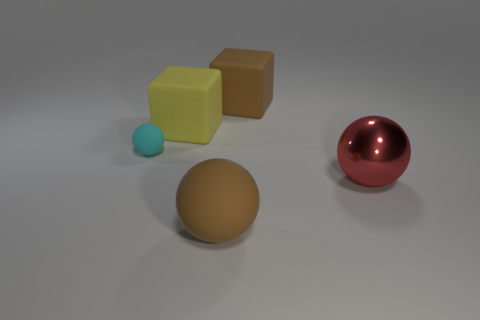Are there any tiny yellow balls made of the same material as the large yellow block?
Your answer should be very brief. No. There is a yellow thing; what shape is it?
Your answer should be compact. Cube. Do the brown block and the yellow rubber block have the same size?
Provide a short and direct response. Yes. What number of other things are there of the same shape as the large red metal thing?
Provide a short and direct response. 2. What is the shape of the matte object behind the big yellow matte thing?
Give a very brief answer. Cube. Does the brown matte thing behind the red metallic sphere have the same shape as the tiny object left of the yellow matte thing?
Your answer should be compact. No. Are there an equal number of brown objects that are in front of the tiny cyan rubber thing and shiny objects?
Offer a terse response. Yes. Is there anything else that has the same size as the red ball?
Your response must be concise. Yes. What material is the big red object that is the same shape as the tiny cyan matte object?
Make the answer very short. Metal. There is a brown thing that is in front of the rubber cube behind the yellow object; what shape is it?
Make the answer very short. Sphere. 